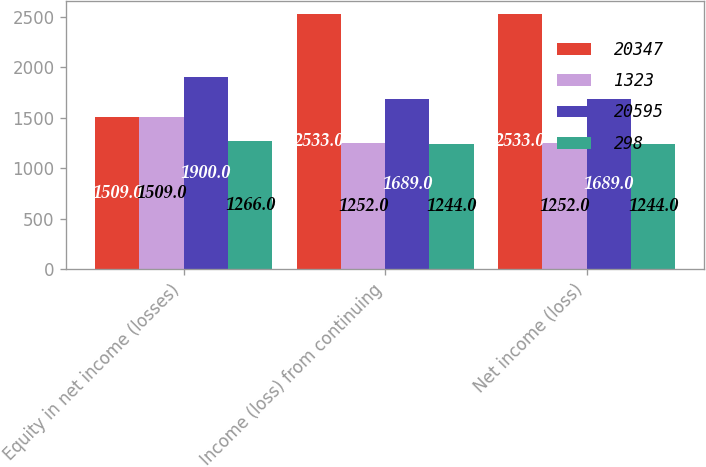Convert chart to OTSL. <chart><loc_0><loc_0><loc_500><loc_500><stacked_bar_chart><ecel><fcel>Equity in net income (losses)<fcel>Income (loss) from continuing<fcel>Net income (loss)<nl><fcel>20347<fcel>1509<fcel>2533<fcel>2533<nl><fcel>1323<fcel>1509<fcel>1252<fcel>1252<nl><fcel>20595<fcel>1900<fcel>1689<fcel>1689<nl><fcel>298<fcel>1266<fcel>1244<fcel>1244<nl></chart> 